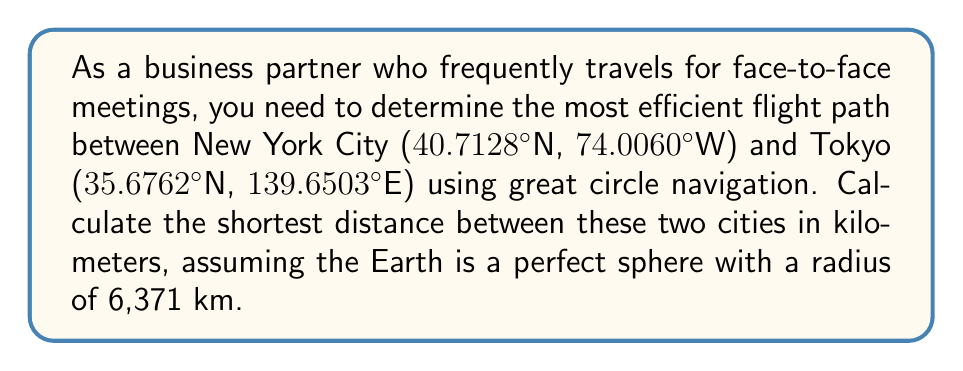Solve this math problem. To solve this problem, we'll use the great circle distance formula, which gives the shortest distance between two points on a sphere. The formula is:

$$d = R \cdot \arccos(\sin(\phi_1) \cdot \sin(\phi_2) + \cos(\phi_1) \cdot \cos(\phi_2) \cdot \cos(\Delta \lambda))$$

Where:
- $d$ is the distance between the two points along the great circle
- $R$ is the radius of the Earth
- $\phi_1$ and $\phi_2$ are the latitudes of the two points in radians
- $\Delta \lambda$ is the absolute difference between the longitudes of the two points in radians

Step 1: Convert latitudes and longitudes to radians
New York City: $\phi_1 = 40.7128° \cdot \frac{\pi}{180} = 0.7102$ radians
Tokyo: $\phi_2 = 35.6762° \cdot \frac{\pi}{180} = 0.6225$ radians
$\Delta \lambda = |74.0060°W - 139.6503°E| \cdot \frac{\pi}{180} = 3.7249$ radians

Step 2: Apply the formula
$$\begin{align*}
d &= 6371 \cdot \arccos(\sin(0.7102) \cdot \sin(0.6225) + \cos(0.7102) \cdot \cos(0.6225) \cdot \cos(3.7249)) \\
&= 6371 \cdot \arccos(0.6356 \cdot 0.5843 + 0.7720 \cdot 0.8115 \cdot -0.7954) \\
&= 6371 \cdot \arccos(0.3714 - 0.4991) \\
&= 6371 \cdot \arccos(-0.1277) \\
&= 6371 \cdot 1.6989 \\
&= 10,823.36 \text{ km}
\end{align*}$$
Answer: The shortest distance between New York City and Tokyo using great circle navigation is approximately 10,823 km. 